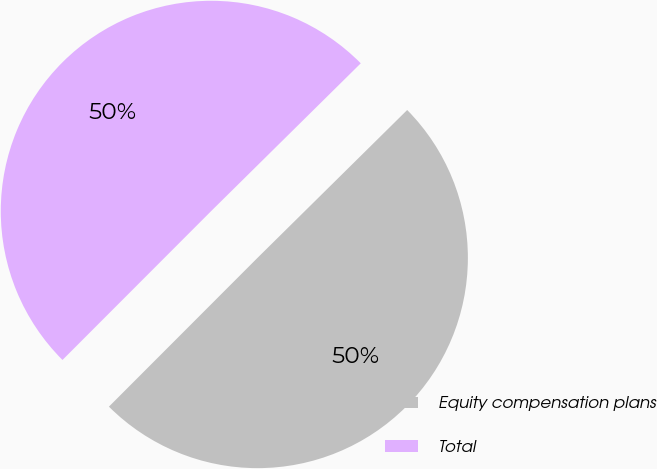Convert chart to OTSL. <chart><loc_0><loc_0><loc_500><loc_500><pie_chart><fcel>Equity compensation plans<fcel>Total<nl><fcel>49.89%<fcel>50.11%<nl></chart> 